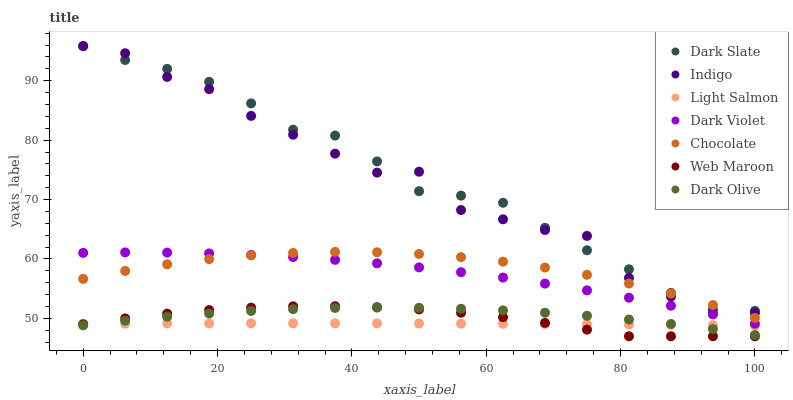Does Light Salmon have the minimum area under the curve?
Answer yes or no. Yes. Does Dark Slate have the maximum area under the curve?
Answer yes or no. Yes. Does Indigo have the minimum area under the curve?
Answer yes or no. No. Does Indigo have the maximum area under the curve?
Answer yes or no. No. Is Light Salmon the smoothest?
Answer yes or no. Yes. Is Indigo the roughest?
Answer yes or no. Yes. Is Dark Olive the smoothest?
Answer yes or no. No. Is Dark Olive the roughest?
Answer yes or no. No. Does Web Maroon have the lowest value?
Answer yes or no. Yes. Does Indigo have the lowest value?
Answer yes or no. No. Does Indigo have the highest value?
Answer yes or no. Yes. Does Dark Olive have the highest value?
Answer yes or no. No. Is Dark Olive less than Dark Slate?
Answer yes or no. Yes. Is Dark Violet greater than Web Maroon?
Answer yes or no. Yes. Does Light Salmon intersect Web Maroon?
Answer yes or no. Yes. Is Light Salmon less than Web Maroon?
Answer yes or no. No. Is Light Salmon greater than Web Maroon?
Answer yes or no. No. Does Dark Olive intersect Dark Slate?
Answer yes or no. No. 